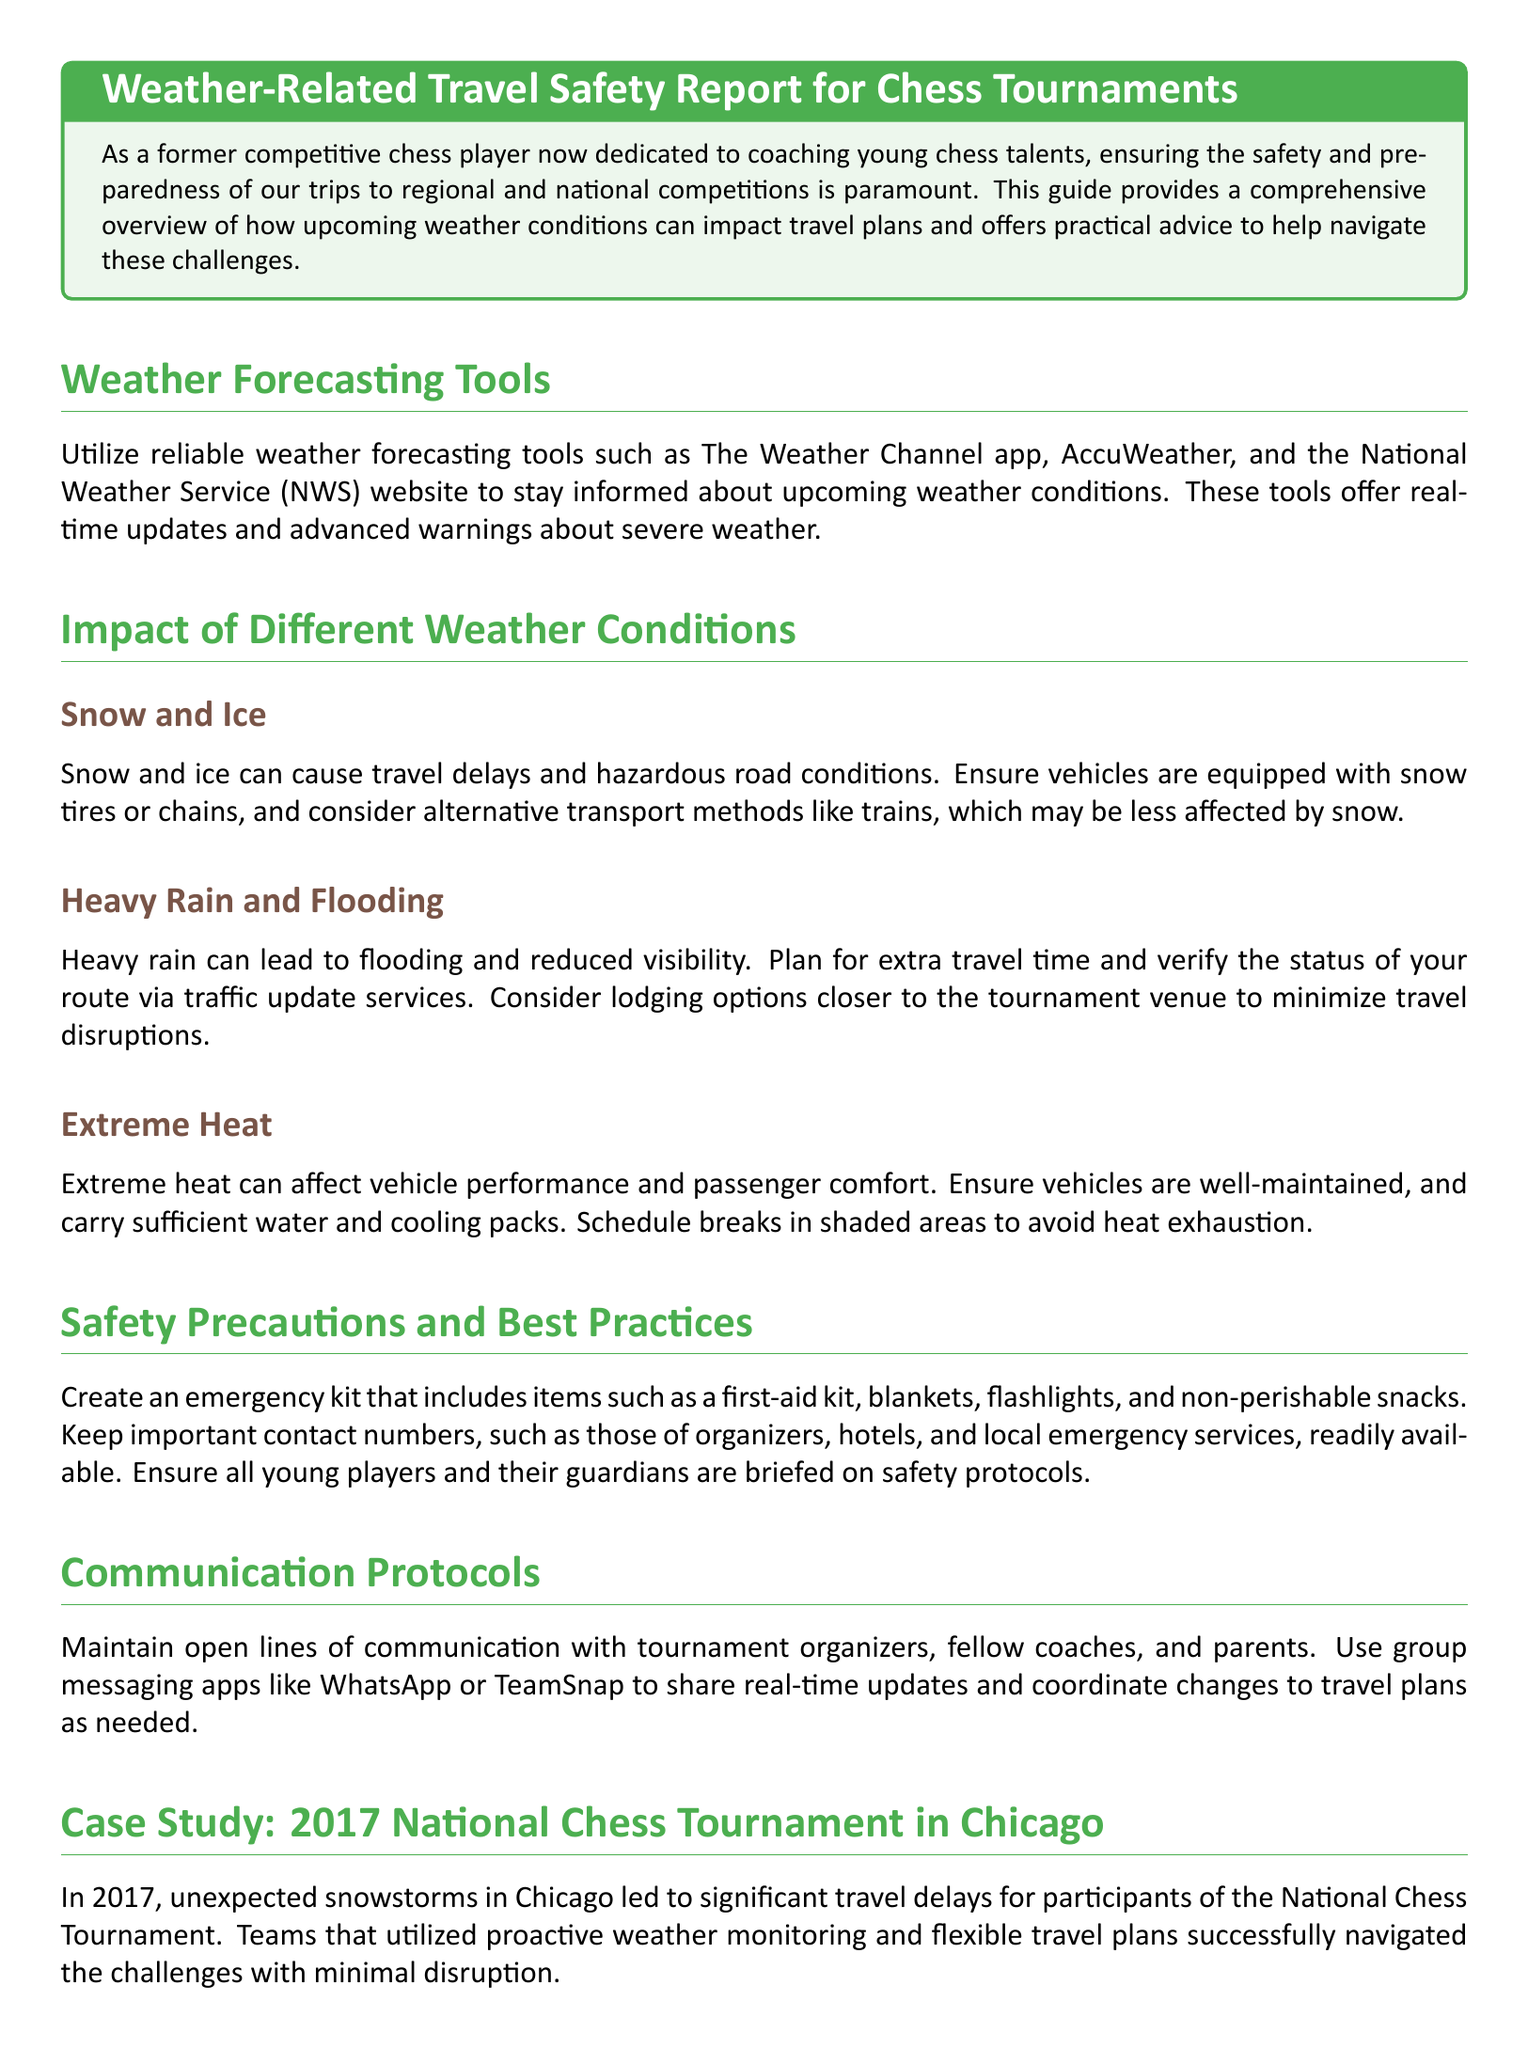What are some reliable weather forecasting tools mentioned? The document lists The Weather Channel app, AccuWeather, and the National Weather Service (NWS) website as reliable tools for weather forecasting.
Answer: The Weather Channel app, AccuWeather, National Weather Service What type of vehicle preparation is recommended for snow and ice? The document suggests that vehicles should be equipped with snow tires or chains to handle snow and ice properly.
Answer: Snow tires or chains What should be included in an emergency kit? The document states that an emergency kit should contain items such as a first-aid kit, blankets, flashlights, and non-perishable snacks.
Answer: First-aid kit, blankets, flashlights, non-perishable snacks What does extreme heat affect according to the report? According to the document, extreme heat can affect vehicle performance and passenger comfort during traveling.
Answer: Vehicle performance and passenger comfort What was the impact of the 2017 snowstorms in Chicago on travel? The document notes that the snowstorms in 2017 led to significant travel delays for participants of the National Chess Tournament.
Answer: Significant travel delays What communication method is recommended by the document? The document recommends using group messaging apps like WhatsApp or TeamSnap to maintain open lines of communication.
Answer: WhatsApp or TeamSnap How can heavy rain affect visibility? The document explains that heavy rain can lead to reduced visibility, making travel more difficult.
Answer: Reduced visibility What is a suggested lodging strategy during heavy rain? The document advises verifying the status of your route and considering lodging options closer to the tournament venue to minimize travel disruptions.
Answer: Lodging options closer to the tournament venue 